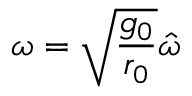Convert formula to latex. <formula><loc_0><loc_0><loc_500><loc_500>\omega = \sqrt { \frac { g _ { 0 } } { r _ { 0 } } } \hat { \omega }</formula> 